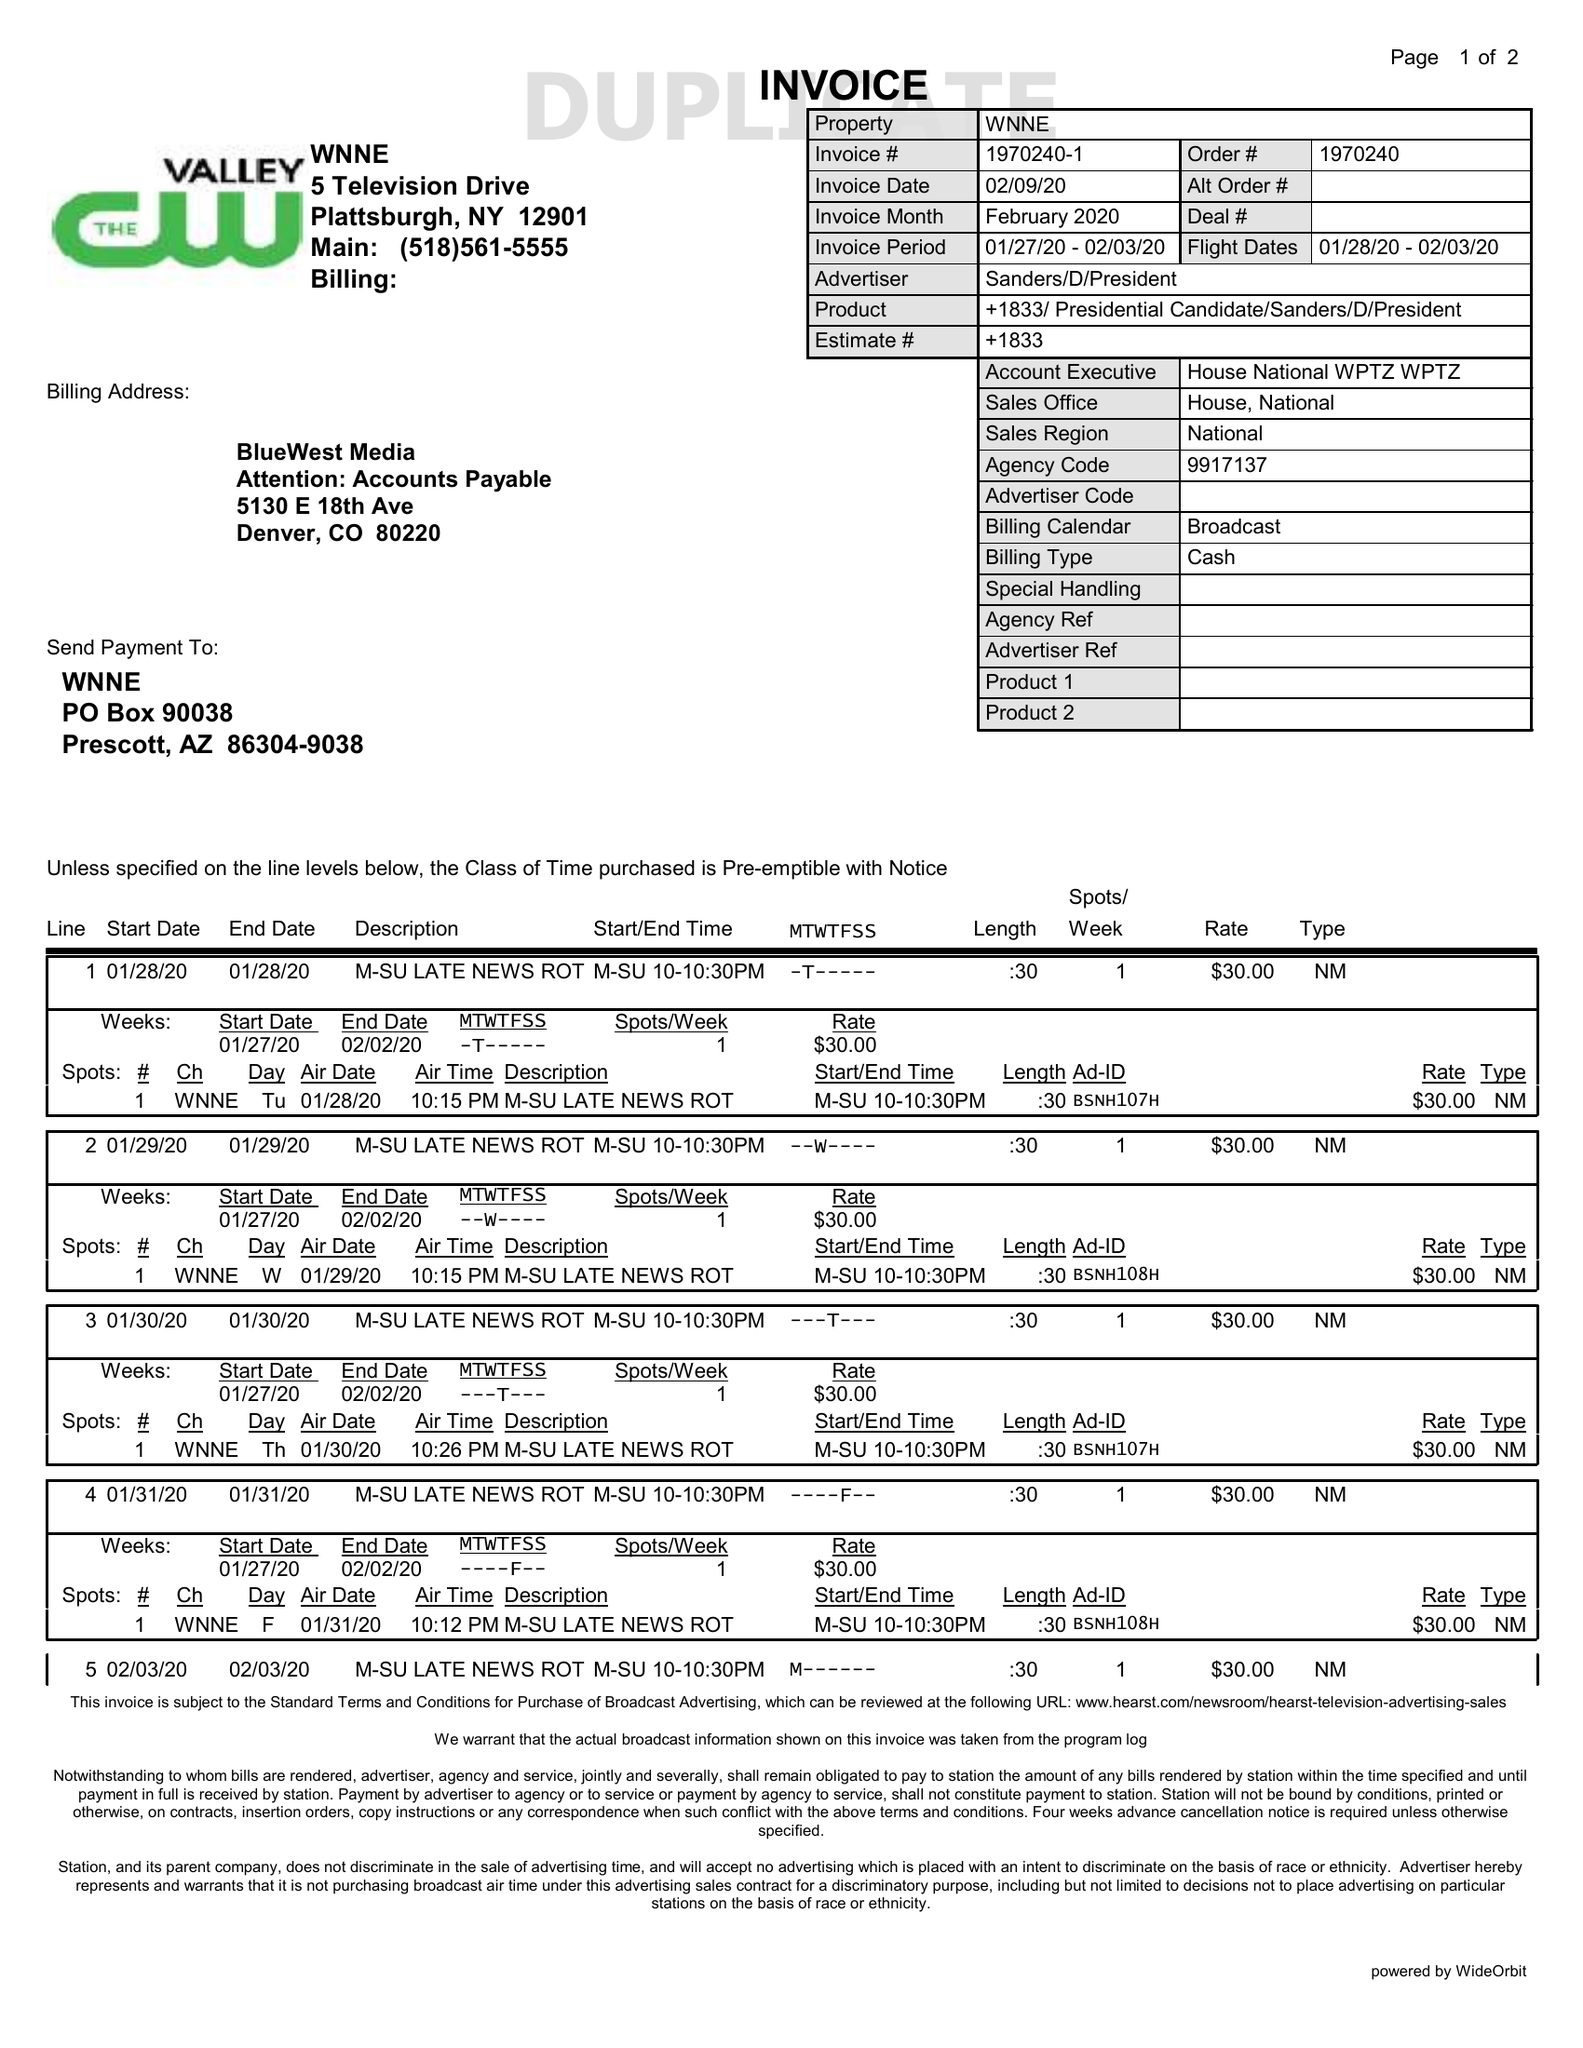What is the value for the advertiser?
Answer the question using a single word or phrase. SANDERS/D/PRESIDENT 